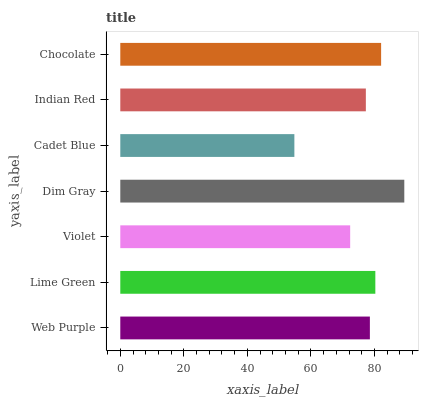Is Cadet Blue the minimum?
Answer yes or no. Yes. Is Dim Gray the maximum?
Answer yes or no. Yes. Is Lime Green the minimum?
Answer yes or no. No. Is Lime Green the maximum?
Answer yes or no. No. Is Lime Green greater than Web Purple?
Answer yes or no. Yes. Is Web Purple less than Lime Green?
Answer yes or no. Yes. Is Web Purple greater than Lime Green?
Answer yes or no. No. Is Lime Green less than Web Purple?
Answer yes or no. No. Is Web Purple the high median?
Answer yes or no. Yes. Is Web Purple the low median?
Answer yes or no. Yes. Is Lime Green the high median?
Answer yes or no. No. Is Chocolate the low median?
Answer yes or no. No. 